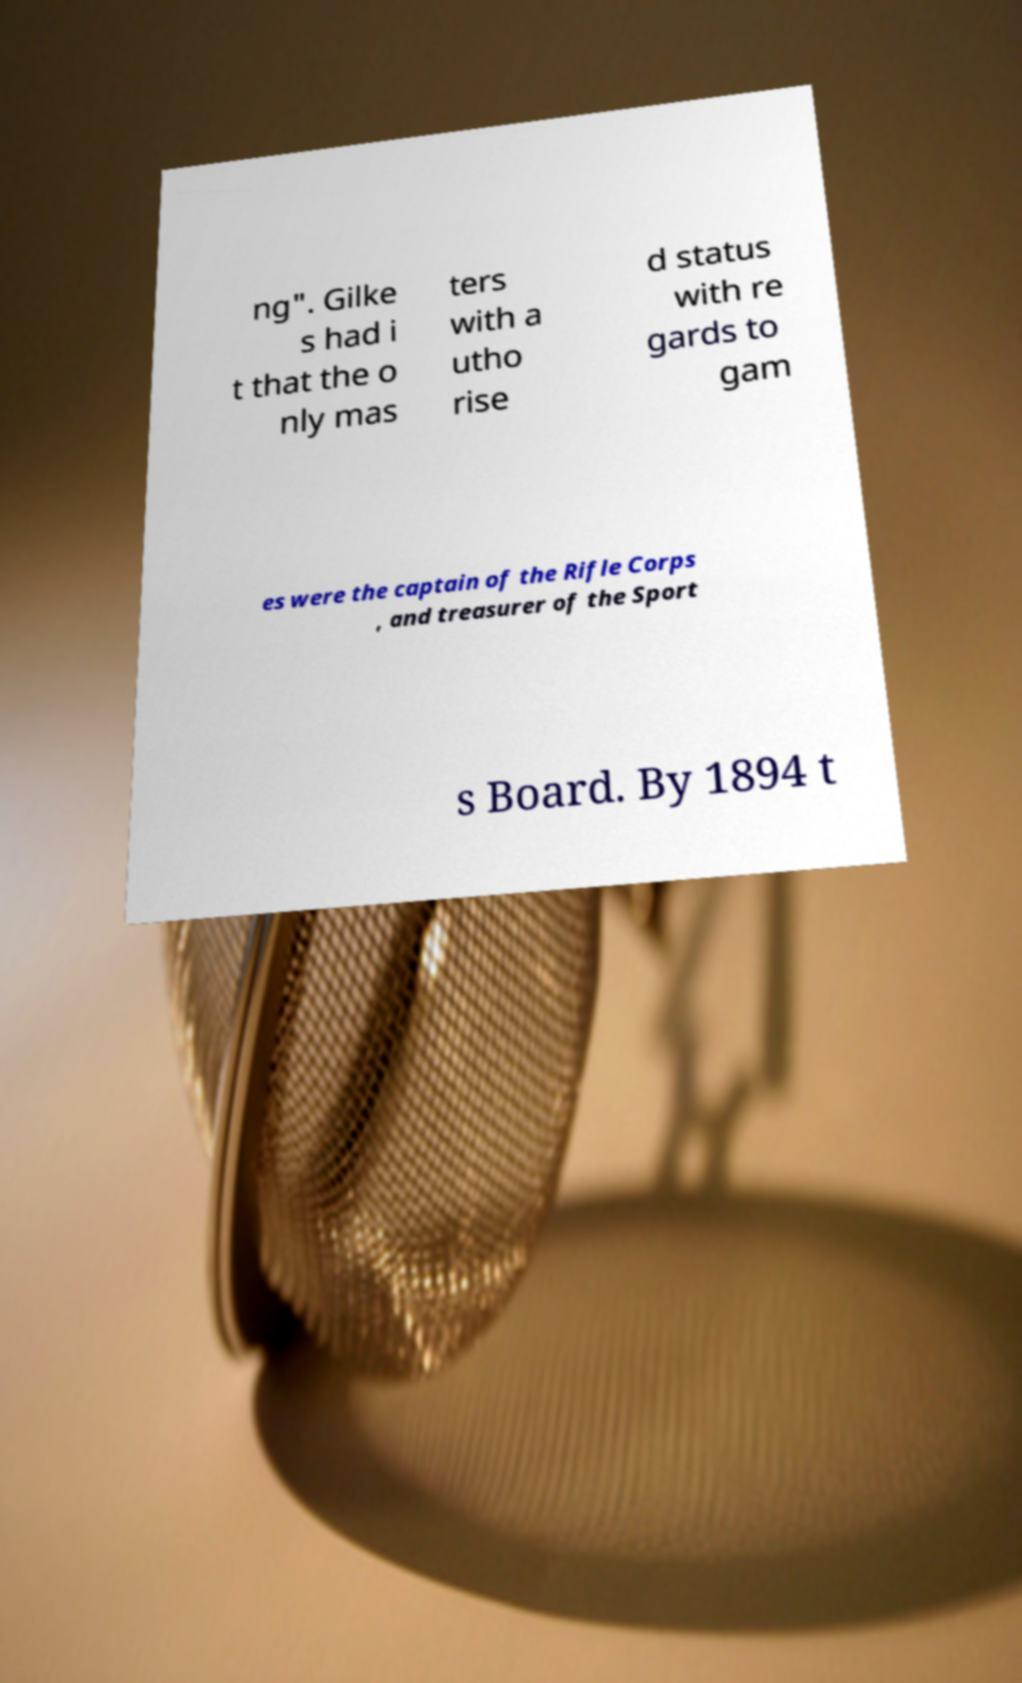Could you assist in decoding the text presented in this image and type it out clearly? ng". Gilke s had i t that the o nly mas ters with a utho rise d status with re gards to gam es were the captain of the Rifle Corps , and treasurer of the Sport s Board. By 1894 t 